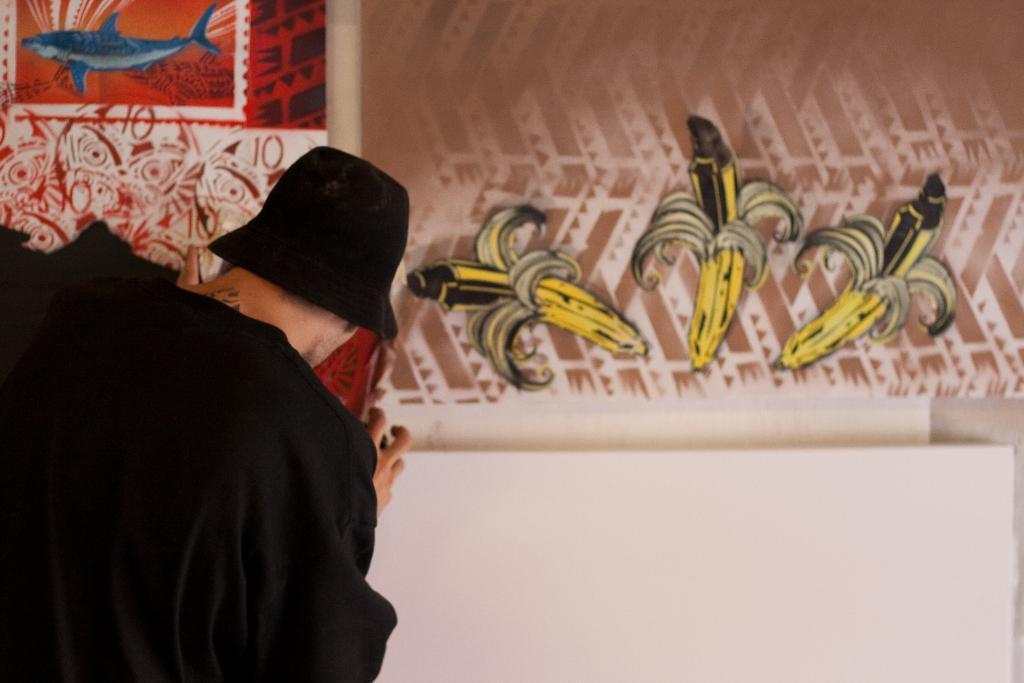Can you describe this image briefly? In the center of the image there is a person wearing black color shirt and black color hat. In the background of the image there are paintings. 